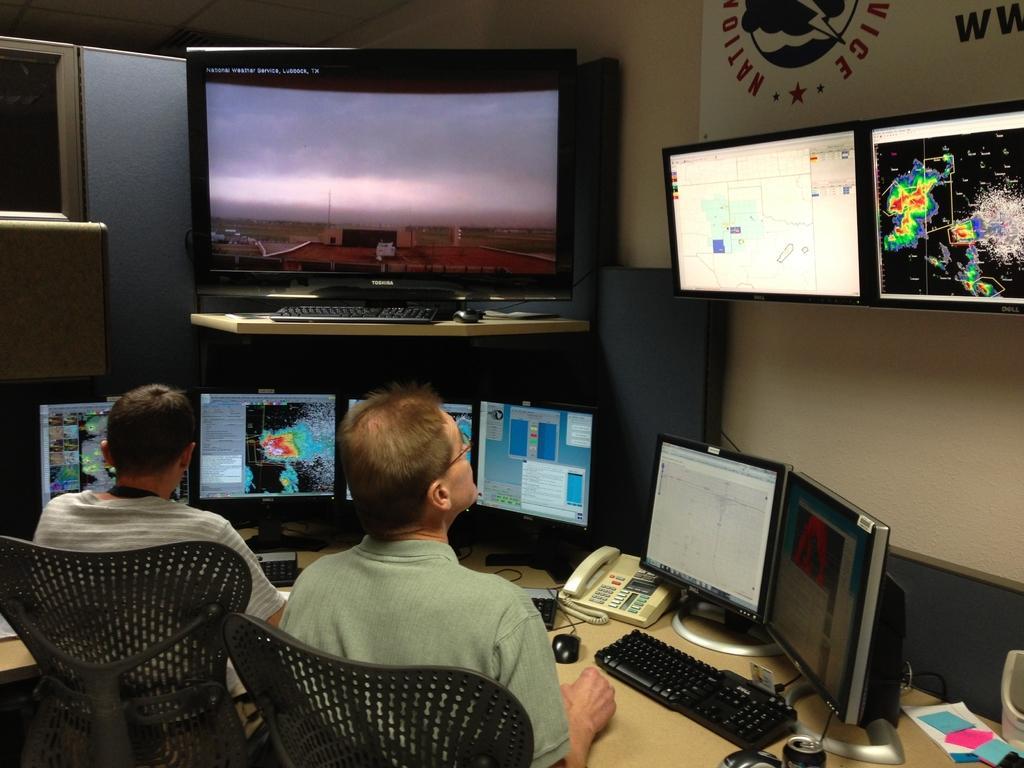Could you give a brief overview of what you see in this image? As we can see in the image there is a wall, few televisions, a banner and two people sitting on chairs and table. On table there is a keyboard, screens, telephone, mouse, tin and papers. 